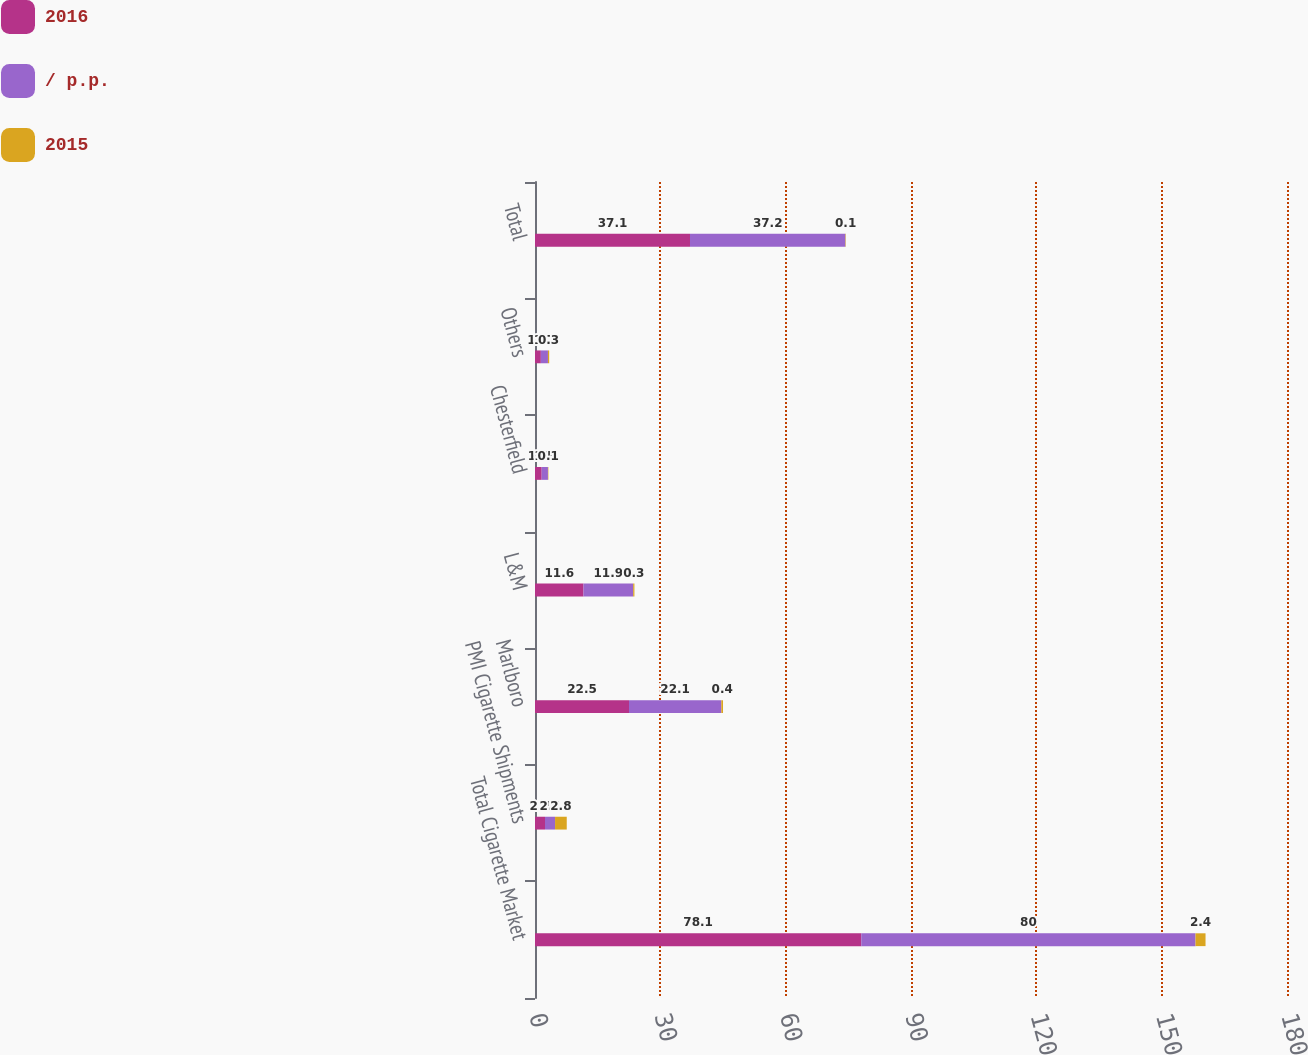Convert chart to OTSL. <chart><loc_0><loc_0><loc_500><loc_500><stacked_bar_chart><ecel><fcel>Total Cigarette Market<fcel>PMI Cigarette Shipments<fcel>Marlboro<fcel>L&M<fcel>Chesterfield<fcel>Others<fcel>Total<nl><fcel>2016<fcel>78.1<fcel>2.4<fcel>22.5<fcel>11.6<fcel>1.6<fcel>1.4<fcel>37.1<nl><fcel>/ p.p.<fcel>80<fcel>2.4<fcel>22.1<fcel>11.9<fcel>1.5<fcel>1.7<fcel>37.2<nl><fcel>2015<fcel>2.4<fcel>2.8<fcel>0.4<fcel>0.3<fcel>0.1<fcel>0.3<fcel>0.1<nl></chart> 